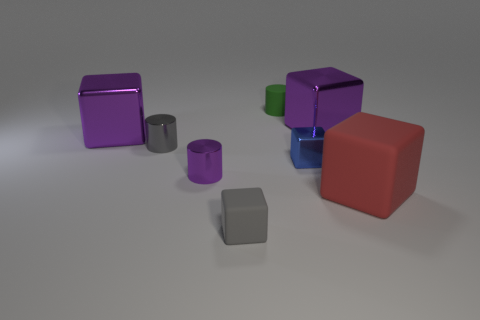There is a thing that is behind the purple metal cylinder and right of the blue metal object; what size is it?
Provide a succinct answer. Large. What number of purple metallic objects are the same size as the purple cylinder?
Make the answer very short. 0. How many rubber things are either brown blocks or blue objects?
Your answer should be very brief. 0. The cylinder to the right of the small matte object in front of the tiny gray metallic cylinder is made of what material?
Make the answer very short. Rubber. How many things are either small gray rubber spheres or metallic objects right of the purple metal cylinder?
Keep it short and to the point. 2. What size is the gray object that is made of the same material as the green object?
Keep it short and to the point. Small. How many gray things are either small objects or shiny things?
Make the answer very short. 2. The thing that is the same color as the small rubber block is what shape?
Your answer should be compact. Cylinder. Is the shape of the big purple shiny thing on the left side of the small gray rubber block the same as the small rubber thing that is behind the red object?
Ensure brevity in your answer.  No. What number of big yellow cylinders are there?
Offer a very short reply. 0. 